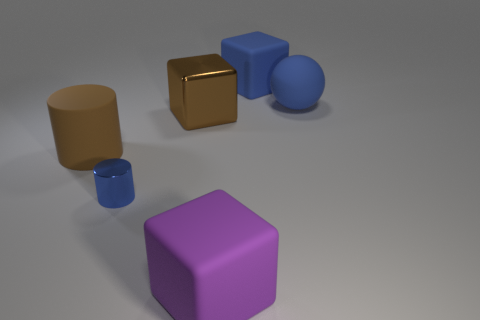Can you describe the lighting and shadows in the image? The scene is illuminated by a light source positioned above and to the left, as deduced by the direction and length of the shadows. Each object casts a shadow to the right side and slightly forward, indicating the light is not directly overhead but angled. The soft edges of the shadows suggest the light source is not a point light but may be an area light, giving the shadows a more diffuse appearance. 